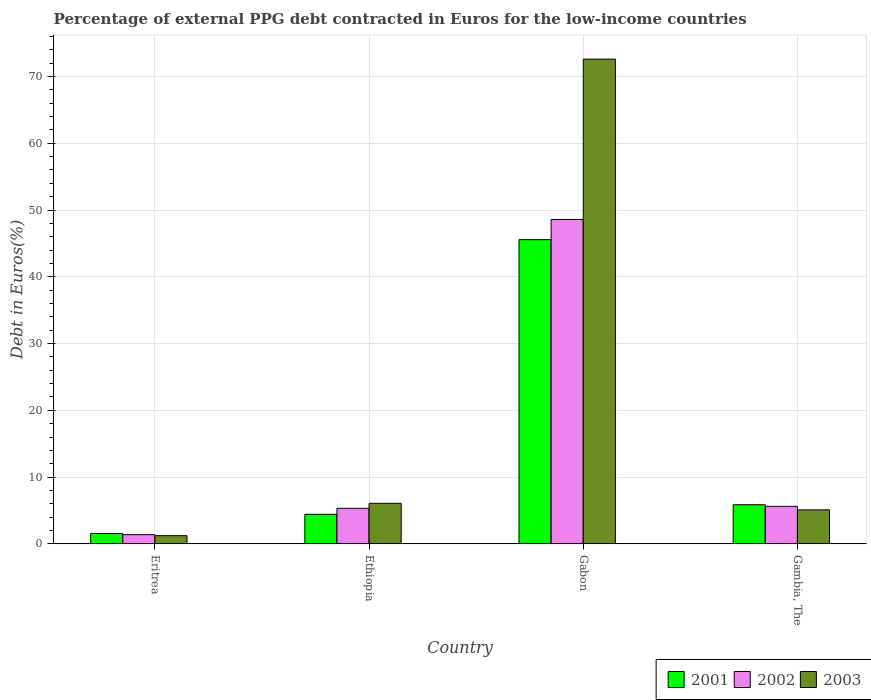How many groups of bars are there?
Make the answer very short. 4. Are the number of bars on each tick of the X-axis equal?
Your answer should be compact. Yes. How many bars are there on the 1st tick from the right?
Offer a terse response. 3. What is the label of the 1st group of bars from the left?
Your response must be concise. Eritrea. What is the percentage of external PPG debt contracted in Euros in 2003 in Gambia, The?
Offer a terse response. 5.09. Across all countries, what is the maximum percentage of external PPG debt contracted in Euros in 2003?
Provide a succinct answer. 72.61. Across all countries, what is the minimum percentage of external PPG debt contracted in Euros in 2002?
Your response must be concise. 1.37. In which country was the percentage of external PPG debt contracted in Euros in 2002 maximum?
Keep it short and to the point. Gabon. In which country was the percentage of external PPG debt contracted in Euros in 2002 minimum?
Provide a short and direct response. Eritrea. What is the total percentage of external PPG debt contracted in Euros in 2002 in the graph?
Keep it short and to the point. 60.91. What is the difference between the percentage of external PPG debt contracted in Euros in 2002 in Eritrea and that in Gambia, The?
Make the answer very short. -4.25. What is the difference between the percentage of external PPG debt contracted in Euros in 2003 in Gabon and the percentage of external PPG debt contracted in Euros in 2002 in Gambia, The?
Your answer should be compact. 66.99. What is the average percentage of external PPG debt contracted in Euros in 2003 per country?
Make the answer very short. 21.25. What is the difference between the percentage of external PPG debt contracted in Euros of/in 2003 and percentage of external PPG debt contracted in Euros of/in 2001 in Eritrea?
Ensure brevity in your answer.  -0.32. What is the ratio of the percentage of external PPG debt contracted in Euros in 2003 in Gabon to that in Gambia, The?
Offer a very short reply. 14.26. Is the percentage of external PPG debt contracted in Euros in 2002 in Eritrea less than that in Gambia, The?
Your response must be concise. Yes. Is the difference between the percentage of external PPG debt contracted in Euros in 2003 in Eritrea and Gabon greater than the difference between the percentage of external PPG debt contracted in Euros in 2001 in Eritrea and Gabon?
Make the answer very short. No. What is the difference between the highest and the second highest percentage of external PPG debt contracted in Euros in 2001?
Provide a succinct answer. 1.43. What is the difference between the highest and the lowest percentage of external PPG debt contracted in Euros in 2003?
Make the answer very short. 71.38. Is it the case that in every country, the sum of the percentage of external PPG debt contracted in Euros in 2003 and percentage of external PPG debt contracted in Euros in 2001 is greater than the percentage of external PPG debt contracted in Euros in 2002?
Provide a succinct answer. Yes. How many bars are there?
Provide a succinct answer. 12. Are all the bars in the graph horizontal?
Provide a short and direct response. No. Does the graph contain any zero values?
Keep it short and to the point. No. Where does the legend appear in the graph?
Offer a very short reply. Bottom right. How many legend labels are there?
Make the answer very short. 3. How are the legend labels stacked?
Your answer should be compact. Horizontal. What is the title of the graph?
Offer a terse response. Percentage of external PPG debt contracted in Euros for the low-income countries. Does "2010" appear as one of the legend labels in the graph?
Your answer should be compact. No. What is the label or title of the X-axis?
Your answer should be very brief. Country. What is the label or title of the Y-axis?
Offer a terse response. Debt in Euros(%). What is the Debt in Euros(%) in 2001 in Eritrea?
Your response must be concise. 1.55. What is the Debt in Euros(%) of 2002 in Eritrea?
Provide a succinct answer. 1.37. What is the Debt in Euros(%) in 2003 in Eritrea?
Offer a terse response. 1.23. What is the Debt in Euros(%) in 2001 in Ethiopia?
Keep it short and to the point. 4.42. What is the Debt in Euros(%) in 2002 in Ethiopia?
Give a very brief answer. 5.33. What is the Debt in Euros(%) in 2003 in Ethiopia?
Give a very brief answer. 6.07. What is the Debt in Euros(%) of 2001 in Gabon?
Ensure brevity in your answer.  45.56. What is the Debt in Euros(%) in 2002 in Gabon?
Give a very brief answer. 48.59. What is the Debt in Euros(%) in 2003 in Gabon?
Provide a succinct answer. 72.61. What is the Debt in Euros(%) of 2001 in Gambia, The?
Ensure brevity in your answer.  5.86. What is the Debt in Euros(%) of 2002 in Gambia, The?
Make the answer very short. 5.62. What is the Debt in Euros(%) of 2003 in Gambia, The?
Give a very brief answer. 5.09. Across all countries, what is the maximum Debt in Euros(%) of 2001?
Provide a short and direct response. 45.56. Across all countries, what is the maximum Debt in Euros(%) of 2002?
Offer a very short reply. 48.59. Across all countries, what is the maximum Debt in Euros(%) in 2003?
Offer a terse response. 72.61. Across all countries, what is the minimum Debt in Euros(%) of 2001?
Provide a short and direct response. 1.55. Across all countries, what is the minimum Debt in Euros(%) of 2002?
Offer a terse response. 1.37. Across all countries, what is the minimum Debt in Euros(%) in 2003?
Keep it short and to the point. 1.23. What is the total Debt in Euros(%) in 2001 in the graph?
Give a very brief answer. 57.39. What is the total Debt in Euros(%) of 2002 in the graph?
Ensure brevity in your answer.  60.91. What is the total Debt in Euros(%) in 2003 in the graph?
Provide a short and direct response. 84.99. What is the difference between the Debt in Euros(%) of 2001 in Eritrea and that in Ethiopia?
Offer a very short reply. -2.88. What is the difference between the Debt in Euros(%) in 2002 in Eritrea and that in Ethiopia?
Your answer should be very brief. -3.96. What is the difference between the Debt in Euros(%) in 2003 in Eritrea and that in Ethiopia?
Your response must be concise. -4.85. What is the difference between the Debt in Euros(%) of 2001 in Eritrea and that in Gabon?
Provide a succinct answer. -44.02. What is the difference between the Debt in Euros(%) in 2002 in Eritrea and that in Gabon?
Keep it short and to the point. -47.21. What is the difference between the Debt in Euros(%) in 2003 in Eritrea and that in Gabon?
Your response must be concise. -71.38. What is the difference between the Debt in Euros(%) of 2001 in Eritrea and that in Gambia, The?
Your response must be concise. -4.31. What is the difference between the Debt in Euros(%) of 2002 in Eritrea and that in Gambia, The?
Ensure brevity in your answer.  -4.25. What is the difference between the Debt in Euros(%) in 2003 in Eritrea and that in Gambia, The?
Your response must be concise. -3.87. What is the difference between the Debt in Euros(%) of 2001 in Ethiopia and that in Gabon?
Your answer should be compact. -41.14. What is the difference between the Debt in Euros(%) of 2002 in Ethiopia and that in Gabon?
Provide a short and direct response. -43.26. What is the difference between the Debt in Euros(%) in 2003 in Ethiopia and that in Gabon?
Make the answer very short. -66.54. What is the difference between the Debt in Euros(%) in 2001 in Ethiopia and that in Gambia, The?
Provide a short and direct response. -1.43. What is the difference between the Debt in Euros(%) in 2002 in Ethiopia and that in Gambia, The?
Offer a very short reply. -0.29. What is the difference between the Debt in Euros(%) of 2003 in Ethiopia and that in Gambia, The?
Your answer should be very brief. 0.98. What is the difference between the Debt in Euros(%) of 2001 in Gabon and that in Gambia, The?
Offer a terse response. 39.7. What is the difference between the Debt in Euros(%) of 2002 in Gabon and that in Gambia, The?
Make the answer very short. 42.97. What is the difference between the Debt in Euros(%) in 2003 in Gabon and that in Gambia, The?
Your answer should be compact. 67.52. What is the difference between the Debt in Euros(%) of 2001 in Eritrea and the Debt in Euros(%) of 2002 in Ethiopia?
Give a very brief answer. -3.78. What is the difference between the Debt in Euros(%) in 2001 in Eritrea and the Debt in Euros(%) in 2003 in Ethiopia?
Offer a very short reply. -4.52. What is the difference between the Debt in Euros(%) of 2002 in Eritrea and the Debt in Euros(%) of 2003 in Ethiopia?
Ensure brevity in your answer.  -4.7. What is the difference between the Debt in Euros(%) in 2001 in Eritrea and the Debt in Euros(%) in 2002 in Gabon?
Your answer should be compact. -47.04. What is the difference between the Debt in Euros(%) in 2001 in Eritrea and the Debt in Euros(%) in 2003 in Gabon?
Provide a short and direct response. -71.06. What is the difference between the Debt in Euros(%) of 2002 in Eritrea and the Debt in Euros(%) of 2003 in Gabon?
Give a very brief answer. -71.23. What is the difference between the Debt in Euros(%) in 2001 in Eritrea and the Debt in Euros(%) in 2002 in Gambia, The?
Ensure brevity in your answer.  -4.07. What is the difference between the Debt in Euros(%) in 2001 in Eritrea and the Debt in Euros(%) in 2003 in Gambia, The?
Offer a very short reply. -3.54. What is the difference between the Debt in Euros(%) of 2002 in Eritrea and the Debt in Euros(%) of 2003 in Gambia, The?
Your answer should be very brief. -3.72. What is the difference between the Debt in Euros(%) in 2001 in Ethiopia and the Debt in Euros(%) in 2002 in Gabon?
Keep it short and to the point. -44.16. What is the difference between the Debt in Euros(%) in 2001 in Ethiopia and the Debt in Euros(%) in 2003 in Gabon?
Provide a short and direct response. -68.18. What is the difference between the Debt in Euros(%) in 2002 in Ethiopia and the Debt in Euros(%) in 2003 in Gabon?
Offer a terse response. -67.28. What is the difference between the Debt in Euros(%) of 2001 in Ethiopia and the Debt in Euros(%) of 2002 in Gambia, The?
Your answer should be very brief. -1.2. What is the difference between the Debt in Euros(%) in 2001 in Ethiopia and the Debt in Euros(%) in 2003 in Gambia, The?
Keep it short and to the point. -0.67. What is the difference between the Debt in Euros(%) in 2002 in Ethiopia and the Debt in Euros(%) in 2003 in Gambia, The?
Provide a succinct answer. 0.24. What is the difference between the Debt in Euros(%) of 2001 in Gabon and the Debt in Euros(%) of 2002 in Gambia, The?
Give a very brief answer. 39.94. What is the difference between the Debt in Euros(%) of 2001 in Gabon and the Debt in Euros(%) of 2003 in Gambia, The?
Make the answer very short. 40.47. What is the difference between the Debt in Euros(%) in 2002 in Gabon and the Debt in Euros(%) in 2003 in Gambia, The?
Offer a very short reply. 43.49. What is the average Debt in Euros(%) of 2001 per country?
Give a very brief answer. 14.35. What is the average Debt in Euros(%) of 2002 per country?
Keep it short and to the point. 15.23. What is the average Debt in Euros(%) in 2003 per country?
Keep it short and to the point. 21.25. What is the difference between the Debt in Euros(%) in 2001 and Debt in Euros(%) in 2002 in Eritrea?
Make the answer very short. 0.18. What is the difference between the Debt in Euros(%) in 2001 and Debt in Euros(%) in 2003 in Eritrea?
Keep it short and to the point. 0.32. What is the difference between the Debt in Euros(%) of 2002 and Debt in Euros(%) of 2003 in Eritrea?
Provide a succinct answer. 0.15. What is the difference between the Debt in Euros(%) of 2001 and Debt in Euros(%) of 2002 in Ethiopia?
Offer a very short reply. -0.91. What is the difference between the Debt in Euros(%) of 2001 and Debt in Euros(%) of 2003 in Ethiopia?
Your answer should be very brief. -1.65. What is the difference between the Debt in Euros(%) of 2002 and Debt in Euros(%) of 2003 in Ethiopia?
Your answer should be very brief. -0.74. What is the difference between the Debt in Euros(%) of 2001 and Debt in Euros(%) of 2002 in Gabon?
Your answer should be very brief. -3.02. What is the difference between the Debt in Euros(%) in 2001 and Debt in Euros(%) in 2003 in Gabon?
Keep it short and to the point. -27.04. What is the difference between the Debt in Euros(%) of 2002 and Debt in Euros(%) of 2003 in Gabon?
Provide a succinct answer. -24.02. What is the difference between the Debt in Euros(%) in 2001 and Debt in Euros(%) in 2002 in Gambia, The?
Your answer should be compact. 0.24. What is the difference between the Debt in Euros(%) of 2001 and Debt in Euros(%) of 2003 in Gambia, The?
Your answer should be very brief. 0.77. What is the difference between the Debt in Euros(%) in 2002 and Debt in Euros(%) in 2003 in Gambia, The?
Make the answer very short. 0.53. What is the ratio of the Debt in Euros(%) of 2001 in Eritrea to that in Ethiopia?
Offer a terse response. 0.35. What is the ratio of the Debt in Euros(%) in 2002 in Eritrea to that in Ethiopia?
Your answer should be compact. 0.26. What is the ratio of the Debt in Euros(%) of 2003 in Eritrea to that in Ethiopia?
Offer a terse response. 0.2. What is the ratio of the Debt in Euros(%) of 2001 in Eritrea to that in Gabon?
Offer a terse response. 0.03. What is the ratio of the Debt in Euros(%) of 2002 in Eritrea to that in Gabon?
Provide a succinct answer. 0.03. What is the ratio of the Debt in Euros(%) of 2003 in Eritrea to that in Gabon?
Ensure brevity in your answer.  0.02. What is the ratio of the Debt in Euros(%) in 2001 in Eritrea to that in Gambia, The?
Your answer should be compact. 0.26. What is the ratio of the Debt in Euros(%) of 2002 in Eritrea to that in Gambia, The?
Your answer should be very brief. 0.24. What is the ratio of the Debt in Euros(%) in 2003 in Eritrea to that in Gambia, The?
Your answer should be very brief. 0.24. What is the ratio of the Debt in Euros(%) in 2001 in Ethiopia to that in Gabon?
Keep it short and to the point. 0.1. What is the ratio of the Debt in Euros(%) of 2002 in Ethiopia to that in Gabon?
Offer a very short reply. 0.11. What is the ratio of the Debt in Euros(%) in 2003 in Ethiopia to that in Gabon?
Ensure brevity in your answer.  0.08. What is the ratio of the Debt in Euros(%) in 2001 in Ethiopia to that in Gambia, The?
Your response must be concise. 0.76. What is the ratio of the Debt in Euros(%) of 2002 in Ethiopia to that in Gambia, The?
Provide a short and direct response. 0.95. What is the ratio of the Debt in Euros(%) of 2003 in Ethiopia to that in Gambia, The?
Provide a short and direct response. 1.19. What is the ratio of the Debt in Euros(%) of 2001 in Gabon to that in Gambia, The?
Keep it short and to the point. 7.78. What is the ratio of the Debt in Euros(%) of 2002 in Gabon to that in Gambia, The?
Your answer should be compact. 8.65. What is the ratio of the Debt in Euros(%) in 2003 in Gabon to that in Gambia, The?
Your answer should be very brief. 14.26. What is the difference between the highest and the second highest Debt in Euros(%) in 2001?
Provide a short and direct response. 39.7. What is the difference between the highest and the second highest Debt in Euros(%) of 2002?
Offer a terse response. 42.97. What is the difference between the highest and the second highest Debt in Euros(%) of 2003?
Give a very brief answer. 66.54. What is the difference between the highest and the lowest Debt in Euros(%) of 2001?
Your answer should be very brief. 44.02. What is the difference between the highest and the lowest Debt in Euros(%) in 2002?
Offer a very short reply. 47.21. What is the difference between the highest and the lowest Debt in Euros(%) of 2003?
Ensure brevity in your answer.  71.38. 